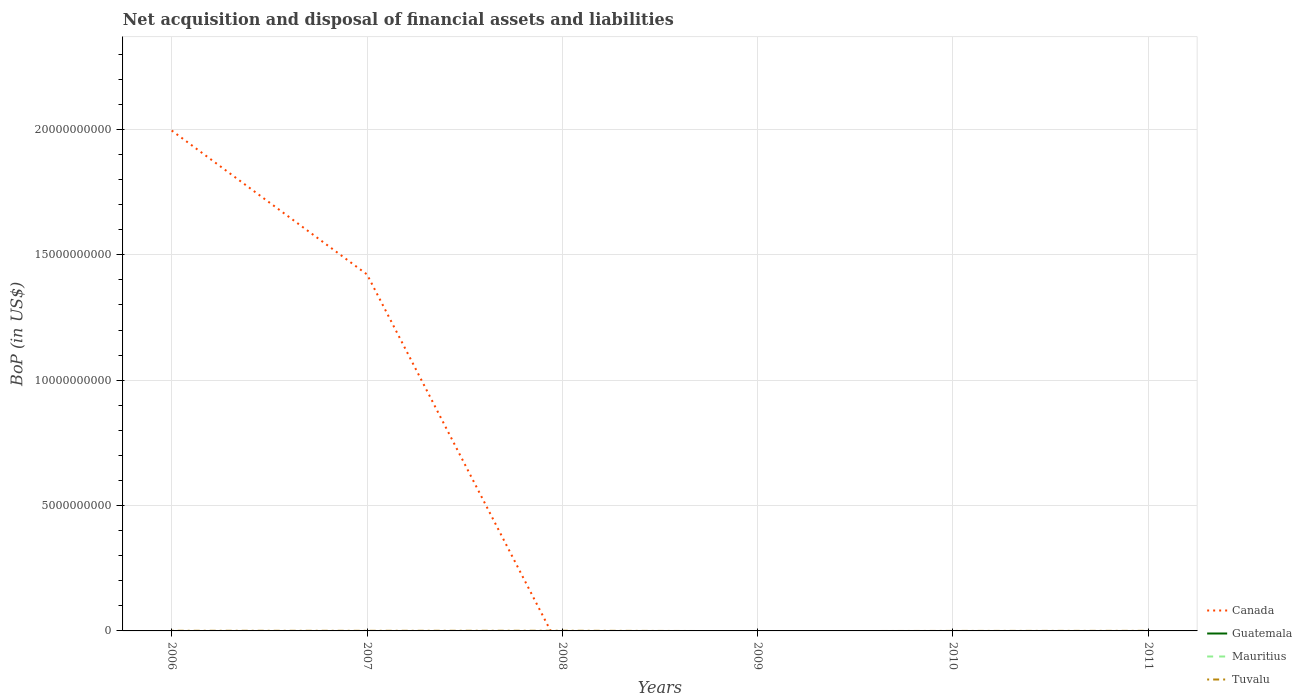Is the number of lines equal to the number of legend labels?
Offer a very short reply. No. What is the total Balance of Payments in Tuvalu in the graph?
Give a very brief answer. 4.25e+06. What is the difference between the highest and the second highest Balance of Payments in Canada?
Your answer should be very brief. 2.00e+1. What is the difference between the highest and the lowest Balance of Payments in Guatemala?
Your answer should be compact. 0. What is the difference between two consecutive major ticks on the Y-axis?
Provide a succinct answer. 5.00e+09. Are the values on the major ticks of Y-axis written in scientific E-notation?
Offer a very short reply. No. Does the graph contain grids?
Offer a very short reply. Yes. Where does the legend appear in the graph?
Provide a short and direct response. Bottom right. What is the title of the graph?
Keep it short and to the point. Net acquisition and disposal of financial assets and liabilities. What is the label or title of the X-axis?
Your answer should be compact. Years. What is the label or title of the Y-axis?
Your response must be concise. BoP (in US$). What is the BoP (in US$) of Canada in 2006?
Keep it short and to the point. 2.00e+1. What is the BoP (in US$) in Guatemala in 2006?
Your answer should be compact. 0. What is the BoP (in US$) of Mauritius in 2006?
Make the answer very short. 0. What is the BoP (in US$) in Tuvalu in 2006?
Make the answer very short. 6.00e+06. What is the BoP (in US$) of Canada in 2007?
Offer a very short reply. 1.42e+1. What is the BoP (in US$) in Guatemala in 2007?
Make the answer very short. 0. What is the BoP (in US$) in Tuvalu in 2007?
Provide a succinct answer. 4.46e+06. What is the BoP (in US$) of Guatemala in 2008?
Keep it short and to the point. 0. What is the BoP (in US$) of Tuvalu in 2008?
Provide a succinct answer. 7.56e+06. What is the BoP (in US$) of Guatemala in 2009?
Your answer should be compact. 0. What is the BoP (in US$) in Mauritius in 2010?
Make the answer very short. 0. What is the BoP (in US$) of Tuvalu in 2010?
Offer a terse response. 2.04e+05. What is the BoP (in US$) of Guatemala in 2011?
Your answer should be compact. 0. What is the BoP (in US$) in Tuvalu in 2011?
Ensure brevity in your answer.  2.96e+06. Across all years, what is the maximum BoP (in US$) of Canada?
Your answer should be compact. 2.00e+1. Across all years, what is the maximum BoP (in US$) of Tuvalu?
Ensure brevity in your answer.  7.56e+06. Across all years, what is the minimum BoP (in US$) in Tuvalu?
Offer a very short reply. 0. What is the total BoP (in US$) in Canada in the graph?
Your answer should be very brief. 3.42e+1. What is the total BoP (in US$) in Guatemala in the graph?
Keep it short and to the point. 0. What is the total BoP (in US$) in Tuvalu in the graph?
Your answer should be compact. 2.12e+07. What is the difference between the BoP (in US$) of Canada in 2006 and that in 2007?
Your response must be concise. 5.74e+09. What is the difference between the BoP (in US$) of Tuvalu in 2006 and that in 2007?
Give a very brief answer. 1.54e+06. What is the difference between the BoP (in US$) of Tuvalu in 2006 and that in 2008?
Your response must be concise. -1.56e+06. What is the difference between the BoP (in US$) of Tuvalu in 2006 and that in 2010?
Provide a succinct answer. 5.80e+06. What is the difference between the BoP (in US$) of Tuvalu in 2006 and that in 2011?
Offer a terse response. 3.04e+06. What is the difference between the BoP (in US$) of Tuvalu in 2007 and that in 2008?
Offer a very short reply. -3.11e+06. What is the difference between the BoP (in US$) in Tuvalu in 2007 and that in 2010?
Make the answer very short. 4.25e+06. What is the difference between the BoP (in US$) of Tuvalu in 2007 and that in 2011?
Offer a very short reply. 1.50e+06. What is the difference between the BoP (in US$) of Tuvalu in 2008 and that in 2010?
Offer a terse response. 7.36e+06. What is the difference between the BoP (in US$) of Tuvalu in 2008 and that in 2011?
Make the answer very short. 4.60e+06. What is the difference between the BoP (in US$) in Tuvalu in 2010 and that in 2011?
Provide a short and direct response. -2.76e+06. What is the difference between the BoP (in US$) of Canada in 2006 and the BoP (in US$) of Tuvalu in 2007?
Ensure brevity in your answer.  2.00e+1. What is the difference between the BoP (in US$) in Canada in 2006 and the BoP (in US$) in Tuvalu in 2008?
Your response must be concise. 2.00e+1. What is the difference between the BoP (in US$) in Canada in 2006 and the BoP (in US$) in Tuvalu in 2010?
Offer a very short reply. 2.00e+1. What is the difference between the BoP (in US$) in Canada in 2006 and the BoP (in US$) in Tuvalu in 2011?
Your response must be concise. 2.00e+1. What is the difference between the BoP (in US$) in Canada in 2007 and the BoP (in US$) in Tuvalu in 2008?
Make the answer very short. 1.42e+1. What is the difference between the BoP (in US$) of Canada in 2007 and the BoP (in US$) of Tuvalu in 2010?
Your answer should be compact. 1.42e+1. What is the difference between the BoP (in US$) in Canada in 2007 and the BoP (in US$) in Tuvalu in 2011?
Offer a terse response. 1.42e+1. What is the average BoP (in US$) in Canada per year?
Ensure brevity in your answer.  5.70e+09. What is the average BoP (in US$) in Mauritius per year?
Offer a terse response. 0. What is the average BoP (in US$) of Tuvalu per year?
Give a very brief answer. 3.53e+06. In the year 2006, what is the difference between the BoP (in US$) in Canada and BoP (in US$) in Tuvalu?
Ensure brevity in your answer.  2.00e+1. In the year 2007, what is the difference between the BoP (in US$) of Canada and BoP (in US$) of Tuvalu?
Offer a terse response. 1.42e+1. What is the ratio of the BoP (in US$) of Canada in 2006 to that in 2007?
Offer a terse response. 1.4. What is the ratio of the BoP (in US$) of Tuvalu in 2006 to that in 2007?
Offer a very short reply. 1.35. What is the ratio of the BoP (in US$) of Tuvalu in 2006 to that in 2008?
Offer a terse response. 0.79. What is the ratio of the BoP (in US$) of Tuvalu in 2006 to that in 2010?
Offer a terse response. 29.41. What is the ratio of the BoP (in US$) of Tuvalu in 2006 to that in 2011?
Your response must be concise. 2.03. What is the ratio of the BoP (in US$) in Tuvalu in 2007 to that in 2008?
Give a very brief answer. 0.59. What is the ratio of the BoP (in US$) in Tuvalu in 2007 to that in 2010?
Your response must be concise. 21.85. What is the ratio of the BoP (in US$) of Tuvalu in 2007 to that in 2011?
Your response must be concise. 1.51. What is the ratio of the BoP (in US$) of Tuvalu in 2008 to that in 2010?
Provide a short and direct response. 37.07. What is the ratio of the BoP (in US$) of Tuvalu in 2008 to that in 2011?
Make the answer very short. 2.55. What is the ratio of the BoP (in US$) in Tuvalu in 2010 to that in 2011?
Ensure brevity in your answer.  0.07. What is the difference between the highest and the second highest BoP (in US$) of Tuvalu?
Your answer should be compact. 1.56e+06. What is the difference between the highest and the lowest BoP (in US$) of Canada?
Make the answer very short. 2.00e+1. What is the difference between the highest and the lowest BoP (in US$) of Tuvalu?
Ensure brevity in your answer.  7.56e+06. 